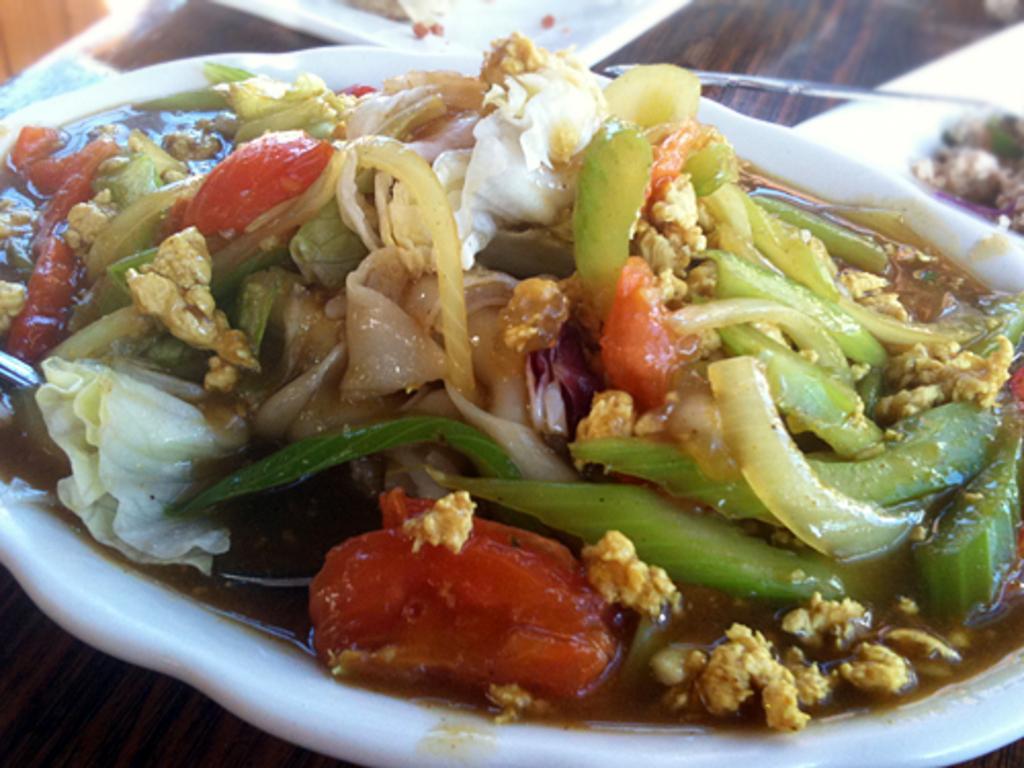Describe this image in one or two sentences. In this image we can see a food dish made of vegetables is kept in a white color bowl. 